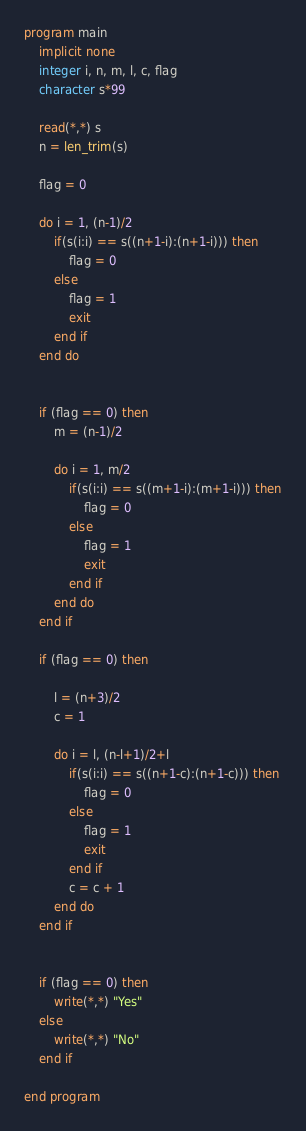<code> <loc_0><loc_0><loc_500><loc_500><_FORTRAN_>program main
    implicit none
    integer i, n, m, l, c, flag
    character s*99

    read(*,*) s
    n = len_trim(s)

    flag = 0

    do i = 1, (n-1)/2
        if(s(i:i) == s((n+1-i):(n+1-i))) then
            flag = 0
        else 
            flag = 1
            exit
        end if
    end do


    if (flag == 0) then
        m = (n-1)/2

        do i = 1, m/2
            if(s(i:i) == s((m+1-i):(m+1-i))) then
                flag = 0
            else 
                flag = 1
                exit
            end if
        end do
    end if
    
    if (flag == 0) then

        l = (n+3)/2
        c = 1

        do i = l, (n-l+1)/2+l
            if(s(i:i) == s((n+1-c):(n+1-c))) then
                flag = 0
            else 
                flag = 1
                exit
            end if
            c = c + 1
        end do
    end if


    if (flag == 0) then
        write(*,*) "Yes"
    else
        write(*,*) "No"
    end if

end program</code> 